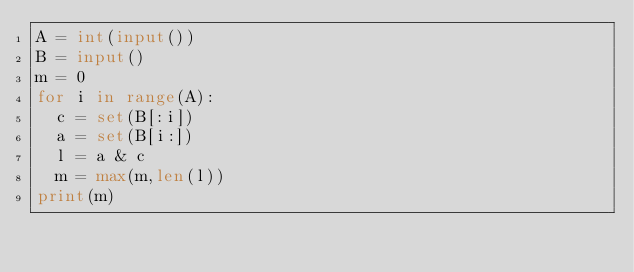<code> <loc_0><loc_0><loc_500><loc_500><_Python_>A = int(input())
B = input()
m = 0
for i in range(A):
  c = set(B[:i])
  a = set(B[i:])
  l = a & c
  m = max(m,len(l))
print(m)</code> 